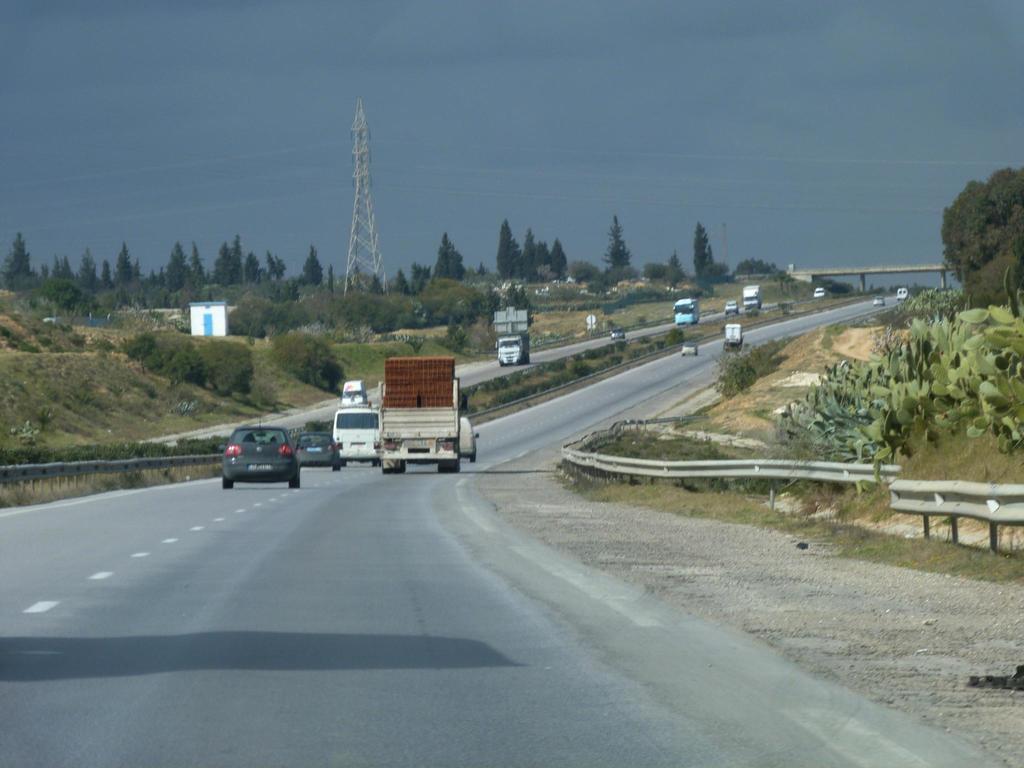How would you summarize this image in a sentence or two? In this picture I can see the road in front, on which there are number of vehicles and I can see the grass and few plants. In the background I can see number of trees, a tower and the sky. I can also see a bridge. 